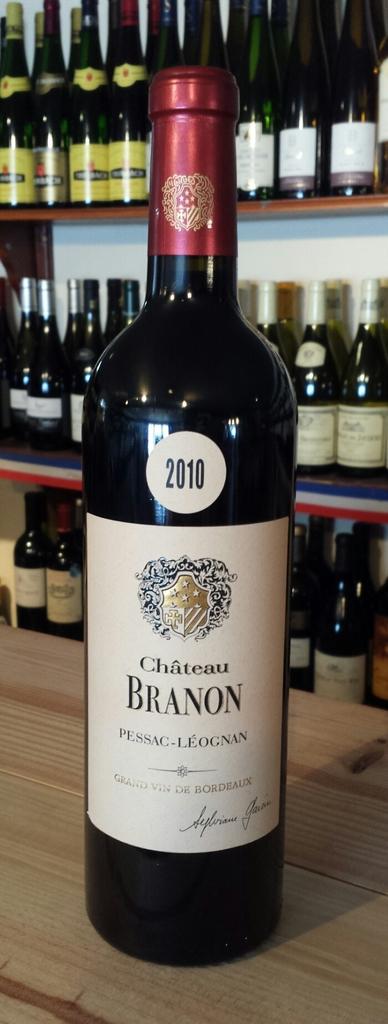What winnery makes  this wine?
Make the answer very short. Chateau branon. 